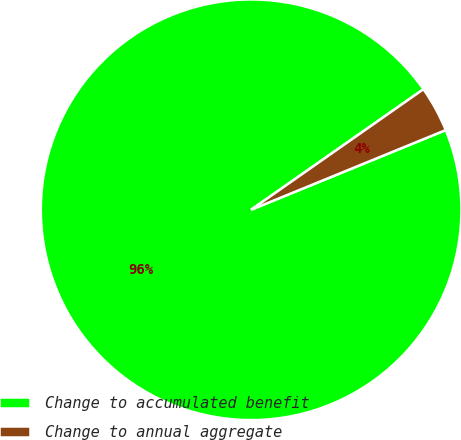Convert chart. <chart><loc_0><loc_0><loc_500><loc_500><pie_chart><fcel>Change to accumulated benefit<fcel>Change to annual aggregate<nl><fcel>96.47%<fcel>3.53%<nl></chart> 